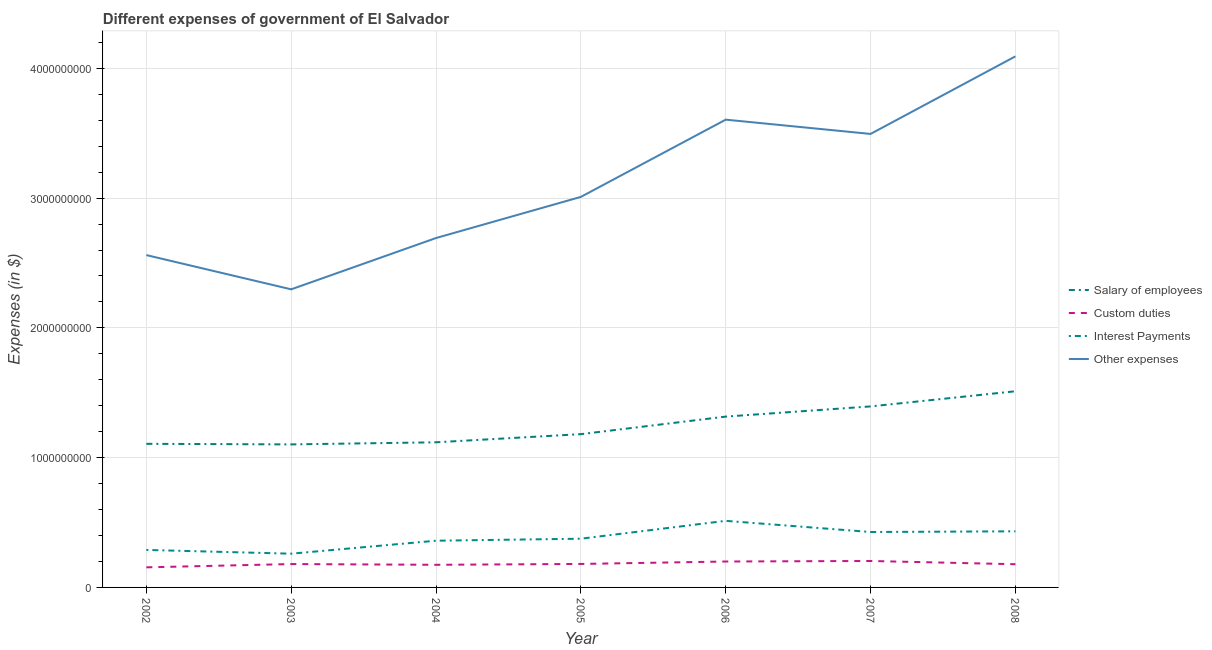How many different coloured lines are there?
Your response must be concise. 4. Is the number of lines equal to the number of legend labels?
Give a very brief answer. Yes. What is the amount spent on other expenses in 2008?
Keep it short and to the point. 4.09e+09. Across all years, what is the maximum amount spent on other expenses?
Your answer should be compact. 4.09e+09. Across all years, what is the minimum amount spent on other expenses?
Your response must be concise. 2.30e+09. In which year was the amount spent on interest payments maximum?
Provide a short and direct response. 2006. What is the total amount spent on custom duties in the graph?
Ensure brevity in your answer.  1.27e+09. What is the difference between the amount spent on custom duties in 2003 and that in 2008?
Offer a very short reply. 1.30e+06. What is the difference between the amount spent on interest payments in 2007 and the amount spent on salary of employees in 2005?
Keep it short and to the point. -7.54e+08. What is the average amount spent on interest payments per year?
Your answer should be compact. 3.80e+08. In the year 2003, what is the difference between the amount spent on custom duties and amount spent on salary of employees?
Provide a short and direct response. -9.22e+08. What is the ratio of the amount spent on other expenses in 2007 to that in 2008?
Offer a very short reply. 0.85. What is the difference between the highest and the second highest amount spent on interest payments?
Your answer should be compact. 8.07e+07. What is the difference between the highest and the lowest amount spent on salary of employees?
Provide a short and direct response. 4.10e+08. Is the sum of the amount spent on custom duties in 2002 and 2007 greater than the maximum amount spent on interest payments across all years?
Keep it short and to the point. No. Is it the case that in every year, the sum of the amount spent on interest payments and amount spent on custom duties is greater than the sum of amount spent on other expenses and amount spent on salary of employees?
Give a very brief answer. No. Is it the case that in every year, the sum of the amount spent on salary of employees and amount spent on custom duties is greater than the amount spent on interest payments?
Provide a short and direct response. Yes. Does the amount spent on salary of employees monotonically increase over the years?
Your answer should be compact. No. Is the amount spent on salary of employees strictly less than the amount spent on other expenses over the years?
Ensure brevity in your answer.  Yes. How many lines are there?
Keep it short and to the point. 4. What is the difference between two consecutive major ticks on the Y-axis?
Your response must be concise. 1.00e+09. Are the values on the major ticks of Y-axis written in scientific E-notation?
Give a very brief answer. No. Does the graph contain any zero values?
Your response must be concise. No. Where does the legend appear in the graph?
Your answer should be compact. Center right. How many legend labels are there?
Provide a short and direct response. 4. How are the legend labels stacked?
Give a very brief answer. Vertical. What is the title of the graph?
Give a very brief answer. Different expenses of government of El Salvador. What is the label or title of the X-axis?
Your response must be concise. Year. What is the label or title of the Y-axis?
Keep it short and to the point. Expenses (in $). What is the Expenses (in $) in Salary of employees in 2002?
Your answer should be very brief. 1.11e+09. What is the Expenses (in $) of Custom duties in 2002?
Give a very brief answer. 1.55e+08. What is the Expenses (in $) in Interest Payments in 2002?
Make the answer very short. 2.89e+08. What is the Expenses (in $) of Other expenses in 2002?
Give a very brief answer. 2.56e+09. What is the Expenses (in $) of Salary of employees in 2003?
Your answer should be very brief. 1.10e+09. What is the Expenses (in $) in Custom duties in 2003?
Keep it short and to the point. 1.80e+08. What is the Expenses (in $) of Interest Payments in 2003?
Provide a succinct answer. 2.60e+08. What is the Expenses (in $) of Other expenses in 2003?
Provide a succinct answer. 2.30e+09. What is the Expenses (in $) of Salary of employees in 2004?
Provide a succinct answer. 1.12e+09. What is the Expenses (in $) in Custom duties in 2004?
Offer a terse response. 1.74e+08. What is the Expenses (in $) of Interest Payments in 2004?
Offer a terse response. 3.60e+08. What is the Expenses (in $) of Other expenses in 2004?
Offer a very short reply. 2.69e+09. What is the Expenses (in $) in Salary of employees in 2005?
Ensure brevity in your answer.  1.18e+09. What is the Expenses (in $) in Custom duties in 2005?
Your answer should be very brief. 1.81e+08. What is the Expenses (in $) in Interest Payments in 2005?
Your answer should be very brief. 3.75e+08. What is the Expenses (in $) in Other expenses in 2005?
Offer a very short reply. 3.01e+09. What is the Expenses (in $) of Salary of employees in 2006?
Your answer should be very brief. 1.32e+09. What is the Expenses (in $) in Custom duties in 2006?
Ensure brevity in your answer.  2.00e+08. What is the Expenses (in $) of Interest Payments in 2006?
Keep it short and to the point. 5.13e+08. What is the Expenses (in $) in Other expenses in 2006?
Provide a succinct answer. 3.60e+09. What is the Expenses (in $) of Salary of employees in 2007?
Keep it short and to the point. 1.39e+09. What is the Expenses (in $) of Custom duties in 2007?
Ensure brevity in your answer.  2.04e+08. What is the Expenses (in $) in Interest Payments in 2007?
Your answer should be very brief. 4.27e+08. What is the Expenses (in $) of Other expenses in 2007?
Give a very brief answer. 3.49e+09. What is the Expenses (in $) in Salary of employees in 2008?
Give a very brief answer. 1.51e+09. What is the Expenses (in $) of Custom duties in 2008?
Your answer should be very brief. 1.79e+08. What is the Expenses (in $) of Interest Payments in 2008?
Your answer should be very brief. 4.32e+08. What is the Expenses (in $) of Other expenses in 2008?
Offer a terse response. 4.09e+09. Across all years, what is the maximum Expenses (in $) in Salary of employees?
Make the answer very short. 1.51e+09. Across all years, what is the maximum Expenses (in $) in Custom duties?
Make the answer very short. 2.04e+08. Across all years, what is the maximum Expenses (in $) of Interest Payments?
Your answer should be very brief. 5.13e+08. Across all years, what is the maximum Expenses (in $) of Other expenses?
Offer a very short reply. 4.09e+09. Across all years, what is the minimum Expenses (in $) of Salary of employees?
Your answer should be compact. 1.10e+09. Across all years, what is the minimum Expenses (in $) of Custom duties?
Offer a very short reply. 1.55e+08. Across all years, what is the minimum Expenses (in $) of Interest Payments?
Offer a very short reply. 2.60e+08. Across all years, what is the minimum Expenses (in $) of Other expenses?
Your answer should be compact. 2.30e+09. What is the total Expenses (in $) in Salary of employees in the graph?
Your response must be concise. 8.73e+09. What is the total Expenses (in $) of Custom duties in the graph?
Make the answer very short. 1.27e+09. What is the total Expenses (in $) of Interest Payments in the graph?
Keep it short and to the point. 2.66e+09. What is the total Expenses (in $) of Other expenses in the graph?
Make the answer very short. 2.18e+1. What is the difference between the Expenses (in $) in Salary of employees in 2002 and that in 2003?
Your answer should be compact. 4.50e+06. What is the difference between the Expenses (in $) in Custom duties in 2002 and that in 2003?
Provide a succinct answer. -2.53e+07. What is the difference between the Expenses (in $) of Interest Payments in 2002 and that in 2003?
Give a very brief answer. 2.89e+07. What is the difference between the Expenses (in $) of Other expenses in 2002 and that in 2003?
Keep it short and to the point. 2.64e+08. What is the difference between the Expenses (in $) of Salary of employees in 2002 and that in 2004?
Provide a succinct answer. -1.18e+07. What is the difference between the Expenses (in $) in Custom duties in 2002 and that in 2004?
Your response must be concise. -1.96e+07. What is the difference between the Expenses (in $) in Interest Payments in 2002 and that in 2004?
Make the answer very short. -7.11e+07. What is the difference between the Expenses (in $) of Other expenses in 2002 and that in 2004?
Offer a very short reply. -1.32e+08. What is the difference between the Expenses (in $) of Salary of employees in 2002 and that in 2005?
Make the answer very short. -7.46e+07. What is the difference between the Expenses (in $) of Custom duties in 2002 and that in 2005?
Offer a very short reply. -2.61e+07. What is the difference between the Expenses (in $) of Interest Payments in 2002 and that in 2005?
Offer a very short reply. -8.65e+07. What is the difference between the Expenses (in $) in Other expenses in 2002 and that in 2005?
Provide a short and direct response. -4.48e+08. What is the difference between the Expenses (in $) in Salary of employees in 2002 and that in 2006?
Offer a very short reply. -2.10e+08. What is the difference between the Expenses (in $) in Custom duties in 2002 and that in 2006?
Offer a very short reply. -4.49e+07. What is the difference between the Expenses (in $) in Interest Payments in 2002 and that in 2006?
Keep it short and to the point. -2.24e+08. What is the difference between the Expenses (in $) in Other expenses in 2002 and that in 2006?
Your answer should be compact. -1.04e+09. What is the difference between the Expenses (in $) of Salary of employees in 2002 and that in 2007?
Offer a very short reply. -2.88e+08. What is the difference between the Expenses (in $) in Custom duties in 2002 and that in 2007?
Offer a very short reply. -4.90e+07. What is the difference between the Expenses (in $) in Interest Payments in 2002 and that in 2007?
Provide a short and direct response. -1.38e+08. What is the difference between the Expenses (in $) of Other expenses in 2002 and that in 2007?
Your answer should be very brief. -9.34e+08. What is the difference between the Expenses (in $) of Salary of employees in 2002 and that in 2008?
Offer a very short reply. -4.05e+08. What is the difference between the Expenses (in $) of Custom duties in 2002 and that in 2008?
Your response must be concise. -2.40e+07. What is the difference between the Expenses (in $) of Interest Payments in 2002 and that in 2008?
Give a very brief answer. -1.44e+08. What is the difference between the Expenses (in $) in Other expenses in 2002 and that in 2008?
Make the answer very short. -1.53e+09. What is the difference between the Expenses (in $) in Salary of employees in 2003 and that in 2004?
Your answer should be very brief. -1.63e+07. What is the difference between the Expenses (in $) of Custom duties in 2003 and that in 2004?
Your response must be concise. 5.70e+06. What is the difference between the Expenses (in $) of Interest Payments in 2003 and that in 2004?
Your answer should be very brief. -1.00e+08. What is the difference between the Expenses (in $) of Other expenses in 2003 and that in 2004?
Ensure brevity in your answer.  -3.95e+08. What is the difference between the Expenses (in $) in Salary of employees in 2003 and that in 2005?
Give a very brief answer. -7.91e+07. What is the difference between the Expenses (in $) of Custom duties in 2003 and that in 2005?
Your answer should be very brief. -8.00e+05. What is the difference between the Expenses (in $) in Interest Payments in 2003 and that in 2005?
Offer a terse response. -1.15e+08. What is the difference between the Expenses (in $) of Other expenses in 2003 and that in 2005?
Keep it short and to the point. -7.12e+08. What is the difference between the Expenses (in $) in Salary of employees in 2003 and that in 2006?
Keep it short and to the point. -2.14e+08. What is the difference between the Expenses (in $) in Custom duties in 2003 and that in 2006?
Provide a succinct answer. -1.96e+07. What is the difference between the Expenses (in $) in Interest Payments in 2003 and that in 2006?
Your answer should be very brief. -2.53e+08. What is the difference between the Expenses (in $) in Other expenses in 2003 and that in 2006?
Offer a terse response. -1.31e+09. What is the difference between the Expenses (in $) in Salary of employees in 2003 and that in 2007?
Your answer should be very brief. -2.93e+08. What is the difference between the Expenses (in $) of Custom duties in 2003 and that in 2007?
Your response must be concise. -2.37e+07. What is the difference between the Expenses (in $) in Interest Payments in 2003 and that in 2007?
Your answer should be very brief. -1.67e+08. What is the difference between the Expenses (in $) in Other expenses in 2003 and that in 2007?
Your answer should be very brief. -1.20e+09. What is the difference between the Expenses (in $) of Salary of employees in 2003 and that in 2008?
Your response must be concise. -4.10e+08. What is the difference between the Expenses (in $) of Custom duties in 2003 and that in 2008?
Keep it short and to the point. 1.30e+06. What is the difference between the Expenses (in $) in Interest Payments in 2003 and that in 2008?
Your answer should be compact. -1.72e+08. What is the difference between the Expenses (in $) of Other expenses in 2003 and that in 2008?
Ensure brevity in your answer.  -1.80e+09. What is the difference between the Expenses (in $) in Salary of employees in 2004 and that in 2005?
Ensure brevity in your answer.  -6.28e+07. What is the difference between the Expenses (in $) of Custom duties in 2004 and that in 2005?
Your answer should be compact. -6.50e+06. What is the difference between the Expenses (in $) of Interest Payments in 2004 and that in 2005?
Provide a short and direct response. -1.54e+07. What is the difference between the Expenses (in $) in Other expenses in 2004 and that in 2005?
Provide a succinct answer. -3.17e+08. What is the difference between the Expenses (in $) in Salary of employees in 2004 and that in 2006?
Offer a very short reply. -1.98e+08. What is the difference between the Expenses (in $) in Custom duties in 2004 and that in 2006?
Your response must be concise. -2.53e+07. What is the difference between the Expenses (in $) of Interest Payments in 2004 and that in 2006?
Ensure brevity in your answer.  -1.53e+08. What is the difference between the Expenses (in $) in Other expenses in 2004 and that in 2006?
Keep it short and to the point. -9.12e+08. What is the difference between the Expenses (in $) of Salary of employees in 2004 and that in 2007?
Give a very brief answer. -2.76e+08. What is the difference between the Expenses (in $) in Custom duties in 2004 and that in 2007?
Your response must be concise. -2.94e+07. What is the difference between the Expenses (in $) of Interest Payments in 2004 and that in 2007?
Provide a succinct answer. -6.71e+07. What is the difference between the Expenses (in $) in Other expenses in 2004 and that in 2007?
Provide a succinct answer. -8.02e+08. What is the difference between the Expenses (in $) in Salary of employees in 2004 and that in 2008?
Keep it short and to the point. -3.93e+08. What is the difference between the Expenses (in $) of Custom duties in 2004 and that in 2008?
Offer a terse response. -4.40e+06. What is the difference between the Expenses (in $) in Interest Payments in 2004 and that in 2008?
Keep it short and to the point. -7.24e+07. What is the difference between the Expenses (in $) of Other expenses in 2004 and that in 2008?
Ensure brevity in your answer.  -1.40e+09. What is the difference between the Expenses (in $) in Salary of employees in 2005 and that in 2006?
Offer a very short reply. -1.35e+08. What is the difference between the Expenses (in $) in Custom duties in 2005 and that in 2006?
Make the answer very short. -1.88e+07. What is the difference between the Expenses (in $) in Interest Payments in 2005 and that in 2006?
Make the answer very short. -1.38e+08. What is the difference between the Expenses (in $) in Other expenses in 2005 and that in 2006?
Give a very brief answer. -5.95e+08. What is the difference between the Expenses (in $) in Salary of employees in 2005 and that in 2007?
Your answer should be very brief. -2.14e+08. What is the difference between the Expenses (in $) of Custom duties in 2005 and that in 2007?
Your response must be concise. -2.29e+07. What is the difference between the Expenses (in $) of Interest Payments in 2005 and that in 2007?
Offer a very short reply. -5.17e+07. What is the difference between the Expenses (in $) in Other expenses in 2005 and that in 2007?
Offer a very short reply. -4.85e+08. What is the difference between the Expenses (in $) in Salary of employees in 2005 and that in 2008?
Your answer should be very brief. -3.30e+08. What is the difference between the Expenses (in $) in Custom duties in 2005 and that in 2008?
Provide a succinct answer. 2.10e+06. What is the difference between the Expenses (in $) in Interest Payments in 2005 and that in 2008?
Your answer should be very brief. -5.70e+07. What is the difference between the Expenses (in $) in Other expenses in 2005 and that in 2008?
Your answer should be compact. -1.08e+09. What is the difference between the Expenses (in $) of Salary of employees in 2006 and that in 2007?
Provide a succinct answer. -7.85e+07. What is the difference between the Expenses (in $) in Custom duties in 2006 and that in 2007?
Offer a very short reply. -4.10e+06. What is the difference between the Expenses (in $) of Interest Payments in 2006 and that in 2007?
Give a very brief answer. 8.60e+07. What is the difference between the Expenses (in $) in Other expenses in 2006 and that in 2007?
Make the answer very short. 1.10e+08. What is the difference between the Expenses (in $) of Salary of employees in 2006 and that in 2008?
Give a very brief answer. -1.95e+08. What is the difference between the Expenses (in $) in Custom duties in 2006 and that in 2008?
Your response must be concise. 2.09e+07. What is the difference between the Expenses (in $) of Interest Payments in 2006 and that in 2008?
Give a very brief answer. 8.07e+07. What is the difference between the Expenses (in $) of Other expenses in 2006 and that in 2008?
Your response must be concise. -4.88e+08. What is the difference between the Expenses (in $) in Salary of employees in 2007 and that in 2008?
Your answer should be compact. -1.17e+08. What is the difference between the Expenses (in $) of Custom duties in 2007 and that in 2008?
Offer a terse response. 2.50e+07. What is the difference between the Expenses (in $) in Interest Payments in 2007 and that in 2008?
Your answer should be compact. -5.30e+06. What is the difference between the Expenses (in $) in Other expenses in 2007 and that in 2008?
Provide a succinct answer. -5.98e+08. What is the difference between the Expenses (in $) of Salary of employees in 2002 and the Expenses (in $) of Custom duties in 2003?
Make the answer very short. 9.26e+08. What is the difference between the Expenses (in $) in Salary of employees in 2002 and the Expenses (in $) in Interest Payments in 2003?
Make the answer very short. 8.47e+08. What is the difference between the Expenses (in $) of Salary of employees in 2002 and the Expenses (in $) of Other expenses in 2003?
Provide a succinct answer. -1.19e+09. What is the difference between the Expenses (in $) in Custom duties in 2002 and the Expenses (in $) in Interest Payments in 2003?
Your response must be concise. -1.05e+08. What is the difference between the Expenses (in $) of Custom duties in 2002 and the Expenses (in $) of Other expenses in 2003?
Your answer should be very brief. -2.14e+09. What is the difference between the Expenses (in $) of Interest Payments in 2002 and the Expenses (in $) of Other expenses in 2003?
Keep it short and to the point. -2.01e+09. What is the difference between the Expenses (in $) in Salary of employees in 2002 and the Expenses (in $) in Custom duties in 2004?
Make the answer very short. 9.32e+08. What is the difference between the Expenses (in $) in Salary of employees in 2002 and the Expenses (in $) in Interest Payments in 2004?
Make the answer very short. 7.47e+08. What is the difference between the Expenses (in $) in Salary of employees in 2002 and the Expenses (in $) in Other expenses in 2004?
Keep it short and to the point. -1.59e+09. What is the difference between the Expenses (in $) in Custom duties in 2002 and the Expenses (in $) in Interest Payments in 2004?
Ensure brevity in your answer.  -2.05e+08. What is the difference between the Expenses (in $) in Custom duties in 2002 and the Expenses (in $) in Other expenses in 2004?
Your response must be concise. -2.54e+09. What is the difference between the Expenses (in $) of Interest Payments in 2002 and the Expenses (in $) of Other expenses in 2004?
Your response must be concise. -2.40e+09. What is the difference between the Expenses (in $) of Salary of employees in 2002 and the Expenses (in $) of Custom duties in 2005?
Give a very brief answer. 9.26e+08. What is the difference between the Expenses (in $) of Salary of employees in 2002 and the Expenses (in $) of Interest Payments in 2005?
Keep it short and to the point. 7.31e+08. What is the difference between the Expenses (in $) of Salary of employees in 2002 and the Expenses (in $) of Other expenses in 2005?
Provide a succinct answer. -1.90e+09. What is the difference between the Expenses (in $) in Custom duties in 2002 and the Expenses (in $) in Interest Payments in 2005?
Make the answer very short. -2.21e+08. What is the difference between the Expenses (in $) in Custom duties in 2002 and the Expenses (in $) in Other expenses in 2005?
Offer a terse response. -2.85e+09. What is the difference between the Expenses (in $) of Interest Payments in 2002 and the Expenses (in $) of Other expenses in 2005?
Offer a terse response. -2.72e+09. What is the difference between the Expenses (in $) in Salary of employees in 2002 and the Expenses (in $) in Custom duties in 2006?
Your answer should be very brief. 9.07e+08. What is the difference between the Expenses (in $) of Salary of employees in 2002 and the Expenses (in $) of Interest Payments in 2006?
Provide a succinct answer. 5.94e+08. What is the difference between the Expenses (in $) of Salary of employees in 2002 and the Expenses (in $) of Other expenses in 2006?
Your answer should be very brief. -2.50e+09. What is the difference between the Expenses (in $) in Custom duties in 2002 and the Expenses (in $) in Interest Payments in 2006?
Provide a short and direct response. -3.58e+08. What is the difference between the Expenses (in $) in Custom duties in 2002 and the Expenses (in $) in Other expenses in 2006?
Provide a short and direct response. -3.45e+09. What is the difference between the Expenses (in $) in Interest Payments in 2002 and the Expenses (in $) in Other expenses in 2006?
Make the answer very short. -3.32e+09. What is the difference between the Expenses (in $) in Salary of employees in 2002 and the Expenses (in $) in Custom duties in 2007?
Offer a terse response. 9.03e+08. What is the difference between the Expenses (in $) in Salary of employees in 2002 and the Expenses (in $) in Interest Payments in 2007?
Provide a short and direct response. 6.80e+08. What is the difference between the Expenses (in $) of Salary of employees in 2002 and the Expenses (in $) of Other expenses in 2007?
Keep it short and to the point. -2.39e+09. What is the difference between the Expenses (in $) in Custom duties in 2002 and the Expenses (in $) in Interest Payments in 2007?
Your answer should be very brief. -2.72e+08. What is the difference between the Expenses (in $) of Custom duties in 2002 and the Expenses (in $) of Other expenses in 2007?
Offer a terse response. -3.34e+09. What is the difference between the Expenses (in $) in Interest Payments in 2002 and the Expenses (in $) in Other expenses in 2007?
Give a very brief answer. -3.21e+09. What is the difference between the Expenses (in $) of Salary of employees in 2002 and the Expenses (in $) of Custom duties in 2008?
Offer a terse response. 9.28e+08. What is the difference between the Expenses (in $) of Salary of employees in 2002 and the Expenses (in $) of Interest Payments in 2008?
Your answer should be compact. 6.74e+08. What is the difference between the Expenses (in $) in Salary of employees in 2002 and the Expenses (in $) in Other expenses in 2008?
Provide a short and direct response. -2.99e+09. What is the difference between the Expenses (in $) in Custom duties in 2002 and the Expenses (in $) in Interest Payments in 2008?
Keep it short and to the point. -2.78e+08. What is the difference between the Expenses (in $) in Custom duties in 2002 and the Expenses (in $) in Other expenses in 2008?
Keep it short and to the point. -3.94e+09. What is the difference between the Expenses (in $) in Interest Payments in 2002 and the Expenses (in $) in Other expenses in 2008?
Ensure brevity in your answer.  -3.80e+09. What is the difference between the Expenses (in $) of Salary of employees in 2003 and the Expenses (in $) of Custom duties in 2004?
Your answer should be very brief. 9.28e+08. What is the difference between the Expenses (in $) in Salary of employees in 2003 and the Expenses (in $) in Interest Payments in 2004?
Offer a very short reply. 7.42e+08. What is the difference between the Expenses (in $) in Salary of employees in 2003 and the Expenses (in $) in Other expenses in 2004?
Provide a short and direct response. -1.59e+09. What is the difference between the Expenses (in $) in Custom duties in 2003 and the Expenses (in $) in Interest Payments in 2004?
Give a very brief answer. -1.80e+08. What is the difference between the Expenses (in $) of Custom duties in 2003 and the Expenses (in $) of Other expenses in 2004?
Your response must be concise. -2.51e+09. What is the difference between the Expenses (in $) of Interest Payments in 2003 and the Expenses (in $) of Other expenses in 2004?
Provide a short and direct response. -2.43e+09. What is the difference between the Expenses (in $) in Salary of employees in 2003 and the Expenses (in $) in Custom duties in 2005?
Offer a very short reply. 9.21e+08. What is the difference between the Expenses (in $) of Salary of employees in 2003 and the Expenses (in $) of Interest Payments in 2005?
Make the answer very short. 7.27e+08. What is the difference between the Expenses (in $) in Salary of employees in 2003 and the Expenses (in $) in Other expenses in 2005?
Provide a succinct answer. -1.91e+09. What is the difference between the Expenses (in $) of Custom duties in 2003 and the Expenses (in $) of Interest Payments in 2005?
Offer a terse response. -1.95e+08. What is the difference between the Expenses (in $) in Custom duties in 2003 and the Expenses (in $) in Other expenses in 2005?
Provide a succinct answer. -2.83e+09. What is the difference between the Expenses (in $) in Interest Payments in 2003 and the Expenses (in $) in Other expenses in 2005?
Offer a very short reply. -2.75e+09. What is the difference between the Expenses (in $) in Salary of employees in 2003 and the Expenses (in $) in Custom duties in 2006?
Provide a short and direct response. 9.02e+08. What is the difference between the Expenses (in $) in Salary of employees in 2003 and the Expenses (in $) in Interest Payments in 2006?
Make the answer very short. 5.89e+08. What is the difference between the Expenses (in $) in Salary of employees in 2003 and the Expenses (in $) in Other expenses in 2006?
Provide a short and direct response. -2.50e+09. What is the difference between the Expenses (in $) in Custom duties in 2003 and the Expenses (in $) in Interest Payments in 2006?
Provide a succinct answer. -3.33e+08. What is the difference between the Expenses (in $) in Custom duties in 2003 and the Expenses (in $) in Other expenses in 2006?
Offer a terse response. -3.42e+09. What is the difference between the Expenses (in $) of Interest Payments in 2003 and the Expenses (in $) of Other expenses in 2006?
Provide a succinct answer. -3.34e+09. What is the difference between the Expenses (in $) in Salary of employees in 2003 and the Expenses (in $) in Custom duties in 2007?
Your answer should be compact. 8.98e+08. What is the difference between the Expenses (in $) of Salary of employees in 2003 and the Expenses (in $) of Interest Payments in 2007?
Make the answer very short. 6.75e+08. What is the difference between the Expenses (in $) of Salary of employees in 2003 and the Expenses (in $) of Other expenses in 2007?
Provide a succinct answer. -2.39e+09. What is the difference between the Expenses (in $) in Custom duties in 2003 and the Expenses (in $) in Interest Payments in 2007?
Your answer should be compact. -2.47e+08. What is the difference between the Expenses (in $) in Custom duties in 2003 and the Expenses (in $) in Other expenses in 2007?
Provide a succinct answer. -3.31e+09. What is the difference between the Expenses (in $) in Interest Payments in 2003 and the Expenses (in $) in Other expenses in 2007?
Your response must be concise. -3.23e+09. What is the difference between the Expenses (in $) in Salary of employees in 2003 and the Expenses (in $) in Custom duties in 2008?
Offer a terse response. 9.23e+08. What is the difference between the Expenses (in $) of Salary of employees in 2003 and the Expenses (in $) of Interest Payments in 2008?
Keep it short and to the point. 6.70e+08. What is the difference between the Expenses (in $) in Salary of employees in 2003 and the Expenses (in $) in Other expenses in 2008?
Offer a very short reply. -2.99e+09. What is the difference between the Expenses (in $) of Custom duties in 2003 and the Expenses (in $) of Interest Payments in 2008?
Provide a short and direct response. -2.52e+08. What is the difference between the Expenses (in $) of Custom duties in 2003 and the Expenses (in $) of Other expenses in 2008?
Your response must be concise. -3.91e+09. What is the difference between the Expenses (in $) in Interest Payments in 2003 and the Expenses (in $) in Other expenses in 2008?
Keep it short and to the point. -3.83e+09. What is the difference between the Expenses (in $) of Salary of employees in 2004 and the Expenses (in $) of Custom duties in 2005?
Your answer should be compact. 9.38e+08. What is the difference between the Expenses (in $) of Salary of employees in 2004 and the Expenses (in $) of Interest Payments in 2005?
Provide a succinct answer. 7.43e+08. What is the difference between the Expenses (in $) of Salary of employees in 2004 and the Expenses (in $) of Other expenses in 2005?
Offer a terse response. -1.89e+09. What is the difference between the Expenses (in $) of Custom duties in 2004 and the Expenses (in $) of Interest Payments in 2005?
Your answer should be compact. -2.01e+08. What is the difference between the Expenses (in $) of Custom duties in 2004 and the Expenses (in $) of Other expenses in 2005?
Provide a short and direct response. -2.84e+09. What is the difference between the Expenses (in $) of Interest Payments in 2004 and the Expenses (in $) of Other expenses in 2005?
Make the answer very short. -2.65e+09. What is the difference between the Expenses (in $) in Salary of employees in 2004 and the Expenses (in $) in Custom duties in 2006?
Offer a terse response. 9.19e+08. What is the difference between the Expenses (in $) of Salary of employees in 2004 and the Expenses (in $) of Interest Payments in 2006?
Give a very brief answer. 6.05e+08. What is the difference between the Expenses (in $) in Salary of employees in 2004 and the Expenses (in $) in Other expenses in 2006?
Your answer should be very brief. -2.49e+09. What is the difference between the Expenses (in $) in Custom duties in 2004 and the Expenses (in $) in Interest Payments in 2006?
Give a very brief answer. -3.39e+08. What is the difference between the Expenses (in $) of Custom duties in 2004 and the Expenses (in $) of Other expenses in 2006?
Offer a very short reply. -3.43e+09. What is the difference between the Expenses (in $) in Interest Payments in 2004 and the Expenses (in $) in Other expenses in 2006?
Provide a succinct answer. -3.24e+09. What is the difference between the Expenses (in $) in Salary of employees in 2004 and the Expenses (in $) in Custom duties in 2007?
Give a very brief answer. 9.15e+08. What is the difference between the Expenses (in $) of Salary of employees in 2004 and the Expenses (in $) of Interest Payments in 2007?
Give a very brief answer. 6.91e+08. What is the difference between the Expenses (in $) of Salary of employees in 2004 and the Expenses (in $) of Other expenses in 2007?
Your answer should be compact. -2.38e+09. What is the difference between the Expenses (in $) of Custom duties in 2004 and the Expenses (in $) of Interest Payments in 2007?
Keep it short and to the point. -2.53e+08. What is the difference between the Expenses (in $) in Custom duties in 2004 and the Expenses (in $) in Other expenses in 2007?
Make the answer very short. -3.32e+09. What is the difference between the Expenses (in $) of Interest Payments in 2004 and the Expenses (in $) of Other expenses in 2007?
Make the answer very short. -3.13e+09. What is the difference between the Expenses (in $) in Salary of employees in 2004 and the Expenses (in $) in Custom duties in 2008?
Offer a terse response. 9.40e+08. What is the difference between the Expenses (in $) in Salary of employees in 2004 and the Expenses (in $) in Interest Payments in 2008?
Your answer should be very brief. 6.86e+08. What is the difference between the Expenses (in $) of Salary of employees in 2004 and the Expenses (in $) of Other expenses in 2008?
Your response must be concise. -2.97e+09. What is the difference between the Expenses (in $) of Custom duties in 2004 and the Expenses (in $) of Interest Payments in 2008?
Your answer should be compact. -2.58e+08. What is the difference between the Expenses (in $) of Custom duties in 2004 and the Expenses (in $) of Other expenses in 2008?
Make the answer very short. -3.92e+09. What is the difference between the Expenses (in $) in Interest Payments in 2004 and the Expenses (in $) in Other expenses in 2008?
Provide a short and direct response. -3.73e+09. What is the difference between the Expenses (in $) in Salary of employees in 2005 and the Expenses (in $) in Custom duties in 2006?
Offer a very short reply. 9.82e+08. What is the difference between the Expenses (in $) in Salary of employees in 2005 and the Expenses (in $) in Interest Payments in 2006?
Provide a short and direct response. 6.68e+08. What is the difference between the Expenses (in $) of Salary of employees in 2005 and the Expenses (in $) of Other expenses in 2006?
Your answer should be very brief. -2.42e+09. What is the difference between the Expenses (in $) of Custom duties in 2005 and the Expenses (in $) of Interest Payments in 2006?
Your response must be concise. -3.32e+08. What is the difference between the Expenses (in $) in Custom duties in 2005 and the Expenses (in $) in Other expenses in 2006?
Provide a succinct answer. -3.42e+09. What is the difference between the Expenses (in $) in Interest Payments in 2005 and the Expenses (in $) in Other expenses in 2006?
Ensure brevity in your answer.  -3.23e+09. What is the difference between the Expenses (in $) in Salary of employees in 2005 and the Expenses (in $) in Custom duties in 2007?
Offer a terse response. 9.77e+08. What is the difference between the Expenses (in $) of Salary of employees in 2005 and the Expenses (in $) of Interest Payments in 2007?
Your answer should be very brief. 7.54e+08. What is the difference between the Expenses (in $) of Salary of employees in 2005 and the Expenses (in $) of Other expenses in 2007?
Offer a terse response. -2.31e+09. What is the difference between the Expenses (in $) in Custom duties in 2005 and the Expenses (in $) in Interest Payments in 2007?
Your answer should be very brief. -2.46e+08. What is the difference between the Expenses (in $) of Custom duties in 2005 and the Expenses (in $) of Other expenses in 2007?
Provide a succinct answer. -3.31e+09. What is the difference between the Expenses (in $) in Interest Payments in 2005 and the Expenses (in $) in Other expenses in 2007?
Offer a very short reply. -3.12e+09. What is the difference between the Expenses (in $) of Salary of employees in 2005 and the Expenses (in $) of Custom duties in 2008?
Give a very brief answer. 1.00e+09. What is the difference between the Expenses (in $) of Salary of employees in 2005 and the Expenses (in $) of Interest Payments in 2008?
Provide a short and direct response. 7.49e+08. What is the difference between the Expenses (in $) of Salary of employees in 2005 and the Expenses (in $) of Other expenses in 2008?
Provide a short and direct response. -2.91e+09. What is the difference between the Expenses (in $) of Custom duties in 2005 and the Expenses (in $) of Interest Payments in 2008?
Offer a terse response. -2.52e+08. What is the difference between the Expenses (in $) in Custom duties in 2005 and the Expenses (in $) in Other expenses in 2008?
Ensure brevity in your answer.  -3.91e+09. What is the difference between the Expenses (in $) in Interest Payments in 2005 and the Expenses (in $) in Other expenses in 2008?
Make the answer very short. -3.72e+09. What is the difference between the Expenses (in $) in Salary of employees in 2006 and the Expenses (in $) in Custom duties in 2007?
Keep it short and to the point. 1.11e+09. What is the difference between the Expenses (in $) in Salary of employees in 2006 and the Expenses (in $) in Interest Payments in 2007?
Your answer should be compact. 8.89e+08. What is the difference between the Expenses (in $) of Salary of employees in 2006 and the Expenses (in $) of Other expenses in 2007?
Make the answer very short. -2.18e+09. What is the difference between the Expenses (in $) of Custom duties in 2006 and the Expenses (in $) of Interest Payments in 2007?
Your answer should be very brief. -2.27e+08. What is the difference between the Expenses (in $) of Custom duties in 2006 and the Expenses (in $) of Other expenses in 2007?
Provide a succinct answer. -3.29e+09. What is the difference between the Expenses (in $) of Interest Payments in 2006 and the Expenses (in $) of Other expenses in 2007?
Your answer should be compact. -2.98e+09. What is the difference between the Expenses (in $) in Salary of employees in 2006 and the Expenses (in $) in Custom duties in 2008?
Offer a terse response. 1.14e+09. What is the difference between the Expenses (in $) of Salary of employees in 2006 and the Expenses (in $) of Interest Payments in 2008?
Your answer should be very brief. 8.84e+08. What is the difference between the Expenses (in $) in Salary of employees in 2006 and the Expenses (in $) in Other expenses in 2008?
Your response must be concise. -2.78e+09. What is the difference between the Expenses (in $) in Custom duties in 2006 and the Expenses (in $) in Interest Payments in 2008?
Provide a succinct answer. -2.33e+08. What is the difference between the Expenses (in $) of Custom duties in 2006 and the Expenses (in $) of Other expenses in 2008?
Make the answer very short. -3.89e+09. What is the difference between the Expenses (in $) of Interest Payments in 2006 and the Expenses (in $) of Other expenses in 2008?
Give a very brief answer. -3.58e+09. What is the difference between the Expenses (in $) in Salary of employees in 2007 and the Expenses (in $) in Custom duties in 2008?
Your answer should be compact. 1.22e+09. What is the difference between the Expenses (in $) of Salary of employees in 2007 and the Expenses (in $) of Interest Payments in 2008?
Provide a succinct answer. 9.62e+08. What is the difference between the Expenses (in $) in Salary of employees in 2007 and the Expenses (in $) in Other expenses in 2008?
Your response must be concise. -2.70e+09. What is the difference between the Expenses (in $) of Custom duties in 2007 and the Expenses (in $) of Interest Payments in 2008?
Your answer should be compact. -2.29e+08. What is the difference between the Expenses (in $) of Custom duties in 2007 and the Expenses (in $) of Other expenses in 2008?
Your response must be concise. -3.89e+09. What is the difference between the Expenses (in $) in Interest Payments in 2007 and the Expenses (in $) in Other expenses in 2008?
Offer a very short reply. -3.67e+09. What is the average Expenses (in $) in Salary of employees per year?
Provide a succinct answer. 1.25e+09. What is the average Expenses (in $) in Custom duties per year?
Provide a succinct answer. 1.82e+08. What is the average Expenses (in $) in Interest Payments per year?
Ensure brevity in your answer.  3.80e+08. What is the average Expenses (in $) in Other expenses per year?
Give a very brief answer. 3.11e+09. In the year 2002, what is the difference between the Expenses (in $) in Salary of employees and Expenses (in $) in Custom duties?
Your answer should be very brief. 9.52e+08. In the year 2002, what is the difference between the Expenses (in $) of Salary of employees and Expenses (in $) of Interest Payments?
Provide a short and direct response. 8.18e+08. In the year 2002, what is the difference between the Expenses (in $) in Salary of employees and Expenses (in $) in Other expenses?
Your answer should be very brief. -1.45e+09. In the year 2002, what is the difference between the Expenses (in $) in Custom duties and Expenses (in $) in Interest Payments?
Offer a terse response. -1.34e+08. In the year 2002, what is the difference between the Expenses (in $) in Custom duties and Expenses (in $) in Other expenses?
Ensure brevity in your answer.  -2.41e+09. In the year 2002, what is the difference between the Expenses (in $) of Interest Payments and Expenses (in $) of Other expenses?
Ensure brevity in your answer.  -2.27e+09. In the year 2003, what is the difference between the Expenses (in $) of Salary of employees and Expenses (in $) of Custom duties?
Make the answer very short. 9.22e+08. In the year 2003, what is the difference between the Expenses (in $) in Salary of employees and Expenses (in $) in Interest Payments?
Keep it short and to the point. 8.42e+08. In the year 2003, what is the difference between the Expenses (in $) of Salary of employees and Expenses (in $) of Other expenses?
Your response must be concise. -1.20e+09. In the year 2003, what is the difference between the Expenses (in $) of Custom duties and Expenses (in $) of Interest Payments?
Offer a very short reply. -7.99e+07. In the year 2003, what is the difference between the Expenses (in $) of Custom duties and Expenses (in $) of Other expenses?
Your answer should be compact. -2.12e+09. In the year 2003, what is the difference between the Expenses (in $) of Interest Payments and Expenses (in $) of Other expenses?
Your answer should be very brief. -2.04e+09. In the year 2004, what is the difference between the Expenses (in $) in Salary of employees and Expenses (in $) in Custom duties?
Ensure brevity in your answer.  9.44e+08. In the year 2004, what is the difference between the Expenses (in $) in Salary of employees and Expenses (in $) in Interest Payments?
Your answer should be very brief. 7.58e+08. In the year 2004, what is the difference between the Expenses (in $) in Salary of employees and Expenses (in $) in Other expenses?
Your answer should be very brief. -1.57e+09. In the year 2004, what is the difference between the Expenses (in $) of Custom duties and Expenses (in $) of Interest Payments?
Your response must be concise. -1.86e+08. In the year 2004, what is the difference between the Expenses (in $) in Custom duties and Expenses (in $) in Other expenses?
Provide a short and direct response. -2.52e+09. In the year 2004, what is the difference between the Expenses (in $) in Interest Payments and Expenses (in $) in Other expenses?
Provide a short and direct response. -2.33e+09. In the year 2005, what is the difference between the Expenses (in $) of Salary of employees and Expenses (in $) of Custom duties?
Your response must be concise. 1.00e+09. In the year 2005, what is the difference between the Expenses (in $) of Salary of employees and Expenses (in $) of Interest Payments?
Your answer should be very brief. 8.06e+08. In the year 2005, what is the difference between the Expenses (in $) of Salary of employees and Expenses (in $) of Other expenses?
Keep it short and to the point. -1.83e+09. In the year 2005, what is the difference between the Expenses (in $) of Custom duties and Expenses (in $) of Interest Payments?
Your answer should be compact. -1.94e+08. In the year 2005, what is the difference between the Expenses (in $) in Custom duties and Expenses (in $) in Other expenses?
Your answer should be very brief. -2.83e+09. In the year 2005, what is the difference between the Expenses (in $) in Interest Payments and Expenses (in $) in Other expenses?
Ensure brevity in your answer.  -2.63e+09. In the year 2006, what is the difference between the Expenses (in $) of Salary of employees and Expenses (in $) of Custom duties?
Keep it short and to the point. 1.12e+09. In the year 2006, what is the difference between the Expenses (in $) in Salary of employees and Expenses (in $) in Interest Payments?
Offer a terse response. 8.03e+08. In the year 2006, what is the difference between the Expenses (in $) of Salary of employees and Expenses (in $) of Other expenses?
Offer a very short reply. -2.29e+09. In the year 2006, what is the difference between the Expenses (in $) of Custom duties and Expenses (in $) of Interest Payments?
Your answer should be very brief. -3.13e+08. In the year 2006, what is the difference between the Expenses (in $) in Custom duties and Expenses (in $) in Other expenses?
Make the answer very short. -3.40e+09. In the year 2006, what is the difference between the Expenses (in $) of Interest Payments and Expenses (in $) of Other expenses?
Ensure brevity in your answer.  -3.09e+09. In the year 2007, what is the difference between the Expenses (in $) in Salary of employees and Expenses (in $) in Custom duties?
Your response must be concise. 1.19e+09. In the year 2007, what is the difference between the Expenses (in $) of Salary of employees and Expenses (in $) of Interest Payments?
Keep it short and to the point. 9.68e+08. In the year 2007, what is the difference between the Expenses (in $) in Salary of employees and Expenses (in $) in Other expenses?
Ensure brevity in your answer.  -2.10e+09. In the year 2007, what is the difference between the Expenses (in $) in Custom duties and Expenses (in $) in Interest Payments?
Make the answer very short. -2.23e+08. In the year 2007, what is the difference between the Expenses (in $) in Custom duties and Expenses (in $) in Other expenses?
Offer a terse response. -3.29e+09. In the year 2007, what is the difference between the Expenses (in $) of Interest Payments and Expenses (in $) of Other expenses?
Keep it short and to the point. -3.07e+09. In the year 2008, what is the difference between the Expenses (in $) of Salary of employees and Expenses (in $) of Custom duties?
Make the answer very short. 1.33e+09. In the year 2008, what is the difference between the Expenses (in $) of Salary of employees and Expenses (in $) of Interest Payments?
Your answer should be very brief. 1.08e+09. In the year 2008, what is the difference between the Expenses (in $) in Salary of employees and Expenses (in $) in Other expenses?
Provide a short and direct response. -2.58e+09. In the year 2008, what is the difference between the Expenses (in $) of Custom duties and Expenses (in $) of Interest Payments?
Provide a short and direct response. -2.54e+08. In the year 2008, what is the difference between the Expenses (in $) in Custom duties and Expenses (in $) in Other expenses?
Your response must be concise. -3.91e+09. In the year 2008, what is the difference between the Expenses (in $) in Interest Payments and Expenses (in $) in Other expenses?
Your answer should be compact. -3.66e+09. What is the ratio of the Expenses (in $) of Salary of employees in 2002 to that in 2003?
Ensure brevity in your answer.  1. What is the ratio of the Expenses (in $) in Custom duties in 2002 to that in 2003?
Keep it short and to the point. 0.86. What is the ratio of the Expenses (in $) in Interest Payments in 2002 to that in 2003?
Offer a very short reply. 1.11. What is the ratio of the Expenses (in $) of Other expenses in 2002 to that in 2003?
Offer a very short reply. 1.11. What is the ratio of the Expenses (in $) in Custom duties in 2002 to that in 2004?
Your answer should be very brief. 0.89. What is the ratio of the Expenses (in $) of Interest Payments in 2002 to that in 2004?
Offer a terse response. 0.8. What is the ratio of the Expenses (in $) of Other expenses in 2002 to that in 2004?
Your answer should be compact. 0.95. What is the ratio of the Expenses (in $) of Salary of employees in 2002 to that in 2005?
Your answer should be very brief. 0.94. What is the ratio of the Expenses (in $) of Custom duties in 2002 to that in 2005?
Ensure brevity in your answer.  0.86. What is the ratio of the Expenses (in $) of Interest Payments in 2002 to that in 2005?
Make the answer very short. 0.77. What is the ratio of the Expenses (in $) in Other expenses in 2002 to that in 2005?
Your response must be concise. 0.85. What is the ratio of the Expenses (in $) in Salary of employees in 2002 to that in 2006?
Your answer should be compact. 0.84. What is the ratio of the Expenses (in $) of Custom duties in 2002 to that in 2006?
Offer a terse response. 0.78. What is the ratio of the Expenses (in $) in Interest Payments in 2002 to that in 2006?
Give a very brief answer. 0.56. What is the ratio of the Expenses (in $) of Other expenses in 2002 to that in 2006?
Ensure brevity in your answer.  0.71. What is the ratio of the Expenses (in $) in Salary of employees in 2002 to that in 2007?
Give a very brief answer. 0.79. What is the ratio of the Expenses (in $) in Custom duties in 2002 to that in 2007?
Your answer should be compact. 0.76. What is the ratio of the Expenses (in $) in Interest Payments in 2002 to that in 2007?
Your response must be concise. 0.68. What is the ratio of the Expenses (in $) of Other expenses in 2002 to that in 2007?
Your answer should be compact. 0.73. What is the ratio of the Expenses (in $) of Salary of employees in 2002 to that in 2008?
Offer a very short reply. 0.73. What is the ratio of the Expenses (in $) in Custom duties in 2002 to that in 2008?
Provide a short and direct response. 0.87. What is the ratio of the Expenses (in $) in Interest Payments in 2002 to that in 2008?
Your response must be concise. 0.67. What is the ratio of the Expenses (in $) in Other expenses in 2002 to that in 2008?
Keep it short and to the point. 0.63. What is the ratio of the Expenses (in $) of Salary of employees in 2003 to that in 2004?
Provide a succinct answer. 0.99. What is the ratio of the Expenses (in $) in Custom duties in 2003 to that in 2004?
Your answer should be very brief. 1.03. What is the ratio of the Expenses (in $) of Interest Payments in 2003 to that in 2004?
Your response must be concise. 0.72. What is the ratio of the Expenses (in $) in Other expenses in 2003 to that in 2004?
Provide a short and direct response. 0.85. What is the ratio of the Expenses (in $) of Salary of employees in 2003 to that in 2005?
Offer a terse response. 0.93. What is the ratio of the Expenses (in $) of Custom duties in 2003 to that in 2005?
Your answer should be very brief. 1. What is the ratio of the Expenses (in $) in Interest Payments in 2003 to that in 2005?
Your answer should be compact. 0.69. What is the ratio of the Expenses (in $) in Other expenses in 2003 to that in 2005?
Provide a succinct answer. 0.76. What is the ratio of the Expenses (in $) of Salary of employees in 2003 to that in 2006?
Provide a succinct answer. 0.84. What is the ratio of the Expenses (in $) of Custom duties in 2003 to that in 2006?
Keep it short and to the point. 0.9. What is the ratio of the Expenses (in $) of Interest Payments in 2003 to that in 2006?
Ensure brevity in your answer.  0.51. What is the ratio of the Expenses (in $) in Other expenses in 2003 to that in 2006?
Offer a very short reply. 0.64. What is the ratio of the Expenses (in $) in Salary of employees in 2003 to that in 2007?
Provide a short and direct response. 0.79. What is the ratio of the Expenses (in $) of Custom duties in 2003 to that in 2007?
Provide a succinct answer. 0.88. What is the ratio of the Expenses (in $) of Interest Payments in 2003 to that in 2007?
Provide a succinct answer. 0.61. What is the ratio of the Expenses (in $) in Other expenses in 2003 to that in 2007?
Provide a short and direct response. 0.66. What is the ratio of the Expenses (in $) in Salary of employees in 2003 to that in 2008?
Make the answer very short. 0.73. What is the ratio of the Expenses (in $) in Custom duties in 2003 to that in 2008?
Provide a succinct answer. 1.01. What is the ratio of the Expenses (in $) in Interest Payments in 2003 to that in 2008?
Ensure brevity in your answer.  0.6. What is the ratio of the Expenses (in $) of Other expenses in 2003 to that in 2008?
Keep it short and to the point. 0.56. What is the ratio of the Expenses (in $) in Salary of employees in 2004 to that in 2005?
Your response must be concise. 0.95. What is the ratio of the Expenses (in $) in Custom duties in 2004 to that in 2005?
Your answer should be very brief. 0.96. What is the ratio of the Expenses (in $) in Other expenses in 2004 to that in 2005?
Keep it short and to the point. 0.89. What is the ratio of the Expenses (in $) of Salary of employees in 2004 to that in 2006?
Your answer should be very brief. 0.85. What is the ratio of the Expenses (in $) in Custom duties in 2004 to that in 2006?
Your answer should be very brief. 0.87. What is the ratio of the Expenses (in $) in Interest Payments in 2004 to that in 2006?
Make the answer very short. 0.7. What is the ratio of the Expenses (in $) in Other expenses in 2004 to that in 2006?
Offer a terse response. 0.75. What is the ratio of the Expenses (in $) of Salary of employees in 2004 to that in 2007?
Provide a succinct answer. 0.8. What is the ratio of the Expenses (in $) of Custom duties in 2004 to that in 2007?
Provide a succinct answer. 0.86. What is the ratio of the Expenses (in $) of Interest Payments in 2004 to that in 2007?
Provide a short and direct response. 0.84. What is the ratio of the Expenses (in $) in Other expenses in 2004 to that in 2007?
Ensure brevity in your answer.  0.77. What is the ratio of the Expenses (in $) of Salary of employees in 2004 to that in 2008?
Your response must be concise. 0.74. What is the ratio of the Expenses (in $) of Custom duties in 2004 to that in 2008?
Your response must be concise. 0.98. What is the ratio of the Expenses (in $) in Interest Payments in 2004 to that in 2008?
Keep it short and to the point. 0.83. What is the ratio of the Expenses (in $) of Other expenses in 2004 to that in 2008?
Offer a very short reply. 0.66. What is the ratio of the Expenses (in $) of Salary of employees in 2005 to that in 2006?
Ensure brevity in your answer.  0.9. What is the ratio of the Expenses (in $) of Custom duties in 2005 to that in 2006?
Keep it short and to the point. 0.91. What is the ratio of the Expenses (in $) of Interest Payments in 2005 to that in 2006?
Keep it short and to the point. 0.73. What is the ratio of the Expenses (in $) in Other expenses in 2005 to that in 2006?
Provide a succinct answer. 0.83. What is the ratio of the Expenses (in $) in Salary of employees in 2005 to that in 2007?
Offer a very short reply. 0.85. What is the ratio of the Expenses (in $) in Custom duties in 2005 to that in 2007?
Your answer should be very brief. 0.89. What is the ratio of the Expenses (in $) in Interest Payments in 2005 to that in 2007?
Your answer should be compact. 0.88. What is the ratio of the Expenses (in $) in Other expenses in 2005 to that in 2007?
Offer a terse response. 0.86. What is the ratio of the Expenses (in $) of Salary of employees in 2005 to that in 2008?
Offer a terse response. 0.78. What is the ratio of the Expenses (in $) in Custom duties in 2005 to that in 2008?
Your response must be concise. 1.01. What is the ratio of the Expenses (in $) in Interest Payments in 2005 to that in 2008?
Make the answer very short. 0.87. What is the ratio of the Expenses (in $) of Other expenses in 2005 to that in 2008?
Your answer should be very brief. 0.74. What is the ratio of the Expenses (in $) of Salary of employees in 2006 to that in 2007?
Ensure brevity in your answer.  0.94. What is the ratio of the Expenses (in $) in Custom duties in 2006 to that in 2007?
Offer a very short reply. 0.98. What is the ratio of the Expenses (in $) of Interest Payments in 2006 to that in 2007?
Provide a succinct answer. 1.2. What is the ratio of the Expenses (in $) of Other expenses in 2006 to that in 2007?
Ensure brevity in your answer.  1.03. What is the ratio of the Expenses (in $) in Salary of employees in 2006 to that in 2008?
Offer a very short reply. 0.87. What is the ratio of the Expenses (in $) of Custom duties in 2006 to that in 2008?
Your response must be concise. 1.12. What is the ratio of the Expenses (in $) of Interest Payments in 2006 to that in 2008?
Your answer should be very brief. 1.19. What is the ratio of the Expenses (in $) of Other expenses in 2006 to that in 2008?
Offer a very short reply. 0.88. What is the ratio of the Expenses (in $) in Salary of employees in 2007 to that in 2008?
Keep it short and to the point. 0.92. What is the ratio of the Expenses (in $) in Custom duties in 2007 to that in 2008?
Offer a very short reply. 1.14. What is the ratio of the Expenses (in $) of Other expenses in 2007 to that in 2008?
Offer a very short reply. 0.85. What is the difference between the highest and the second highest Expenses (in $) of Salary of employees?
Provide a succinct answer. 1.17e+08. What is the difference between the highest and the second highest Expenses (in $) in Custom duties?
Provide a short and direct response. 4.10e+06. What is the difference between the highest and the second highest Expenses (in $) in Interest Payments?
Offer a very short reply. 8.07e+07. What is the difference between the highest and the second highest Expenses (in $) in Other expenses?
Make the answer very short. 4.88e+08. What is the difference between the highest and the lowest Expenses (in $) of Salary of employees?
Make the answer very short. 4.10e+08. What is the difference between the highest and the lowest Expenses (in $) in Custom duties?
Offer a terse response. 4.90e+07. What is the difference between the highest and the lowest Expenses (in $) in Interest Payments?
Keep it short and to the point. 2.53e+08. What is the difference between the highest and the lowest Expenses (in $) in Other expenses?
Provide a short and direct response. 1.80e+09. 